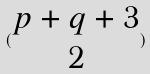<formula> <loc_0><loc_0><loc_500><loc_500>( \begin{matrix} p + q + 3 \\ 2 \end{matrix} )</formula> 